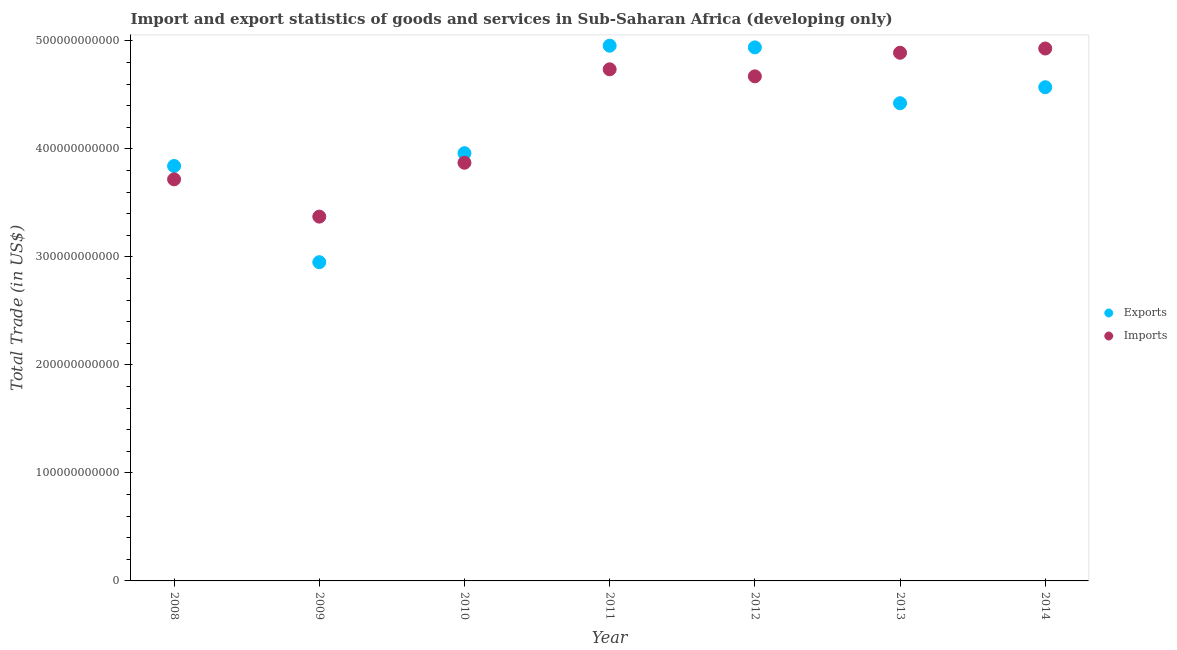What is the imports of goods and services in 2010?
Your answer should be compact. 3.87e+11. Across all years, what is the maximum imports of goods and services?
Offer a very short reply. 4.93e+11. Across all years, what is the minimum imports of goods and services?
Keep it short and to the point. 3.37e+11. What is the total export of goods and services in the graph?
Offer a very short reply. 2.96e+12. What is the difference between the imports of goods and services in 2010 and that in 2011?
Give a very brief answer. -8.65e+1. What is the difference between the export of goods and services in 2010 and the imports of goods and services in 2009?
Give a very brief answer. 5.87e+1. What is the average imports of goods and services per year?
Offer a terse response. 4.31e+11. In the year 2013, what is the difference between the imports of goods and services and export of goods and services?
Ensure brevity in your answer.  4.67e+1. In how many years, is the imports of goods and services greater than 160000000000 US$?
Your answer should be very brief. 7. What is the ratio of the export of goods and services in 2009 to that in 2014?
Provide a short and direct response. 0.65. Is the export of goods and services in 2011 less than that in 2012?
Make the answer very short. No. Is the difference between the imports of goods and services in 2012 and 2014 greater than the difference between the export of goods and services in 2012 and 2014?
Provide a succinct answer. No. What is the difference between the highest and the second highest export of goods and services?
Give a very brief answer. 1.56e+09. What is the difference between the highest and the lowest export of goods and services?
Your answer should be compact. 2.00e+11. Is the imports of goods and services strictly less than the export of goods and services over the years?
Give a very brief answer. No. What is the difference between two consecutive major ticks on the Y-axis?
Provide a succinct answer. 1.00e+11. Are the values on the major ticks of Y-axis written in scientific E-notation?
Offer a terse response. No. Does the graph contain any zero values?
Your answer should be very brief. No. Does the graph contain grids?
Ensure brevity in your answer.  No. How are the legend labels stacked?
Your answer should be very brief. Vertical. What is the title of the graph?
Offer a very short reply. Import and export statistics of goods and services in Sub-Saharan Africa (developing only). What is the label or title of the Y-axis?
Your answer should be very brief. Total Trade (in US$). What is the Total Trade (in US$) in Exports in 2008?
Ensure brevity in your answer.  3.84e+11. What is the Total Trade (in US$) in Imports in 2008?
Provide a succinct answer. 3.72e+11. What is the Total Trade (in US$) in Exports in 2009?
Keep it short and to the point. 2.95e+11. What is the Total Trade (in US$) of Imports in 2009?
Your response must be concise. 3.37e+11. What is the Total Trade (in US$) in Exports in 2010?
Offer a very short reply. 3.96e+11. What is the Total Trade (in US$) in Imports in 2010?
Provide a succinct answer. 3.87e+11. What is the Total Trade (in US$) in Exports in 2011?
Offer a terse response. 4.95e+11. What is the Total Trade (in US$) of Imports in 2011?
Your response must be concise. 4.74e+11. What is the Total Trade (in US$) in Exports in 2012?
Provide a short and direct response. 4.94e+11. What is the Total Trade (in US$) in Imports in 2012?
Provide a short and direct response. 4.67e+11. What is the Total Trade (in US$) in Exports in 2013?
Make the answer very short. 4.42e+11. What is the Total Trade (in US$) of Imports in 2013?
Make the answer very short. 4.89e+11. What is the Total Trade (in US$) of Exports in 2014?
Your response must be concise. 4.57e+11. What is the Total Trade (in US$) of Imports in 2014?
Your response must be concise. 4.93e+11. Across all years, what is the maximum Total Trade (in US$) in Exports?
Provide a succinct answer. 4.95e+11. Across all years, what is the maximum Total Trade (in US$) of Imports?
Your response must be concise. 4.93e+11. Across all years, what is the minimum Total Trade (in US$) in Exports?
Ensure brevity in your answer.  2.95e+11. Across all years, what is the minimum Total Trade (in US$) in Imports?
Offer a very short reply. 3.37e+11. What is the total Total Trade (in US$) in Exports in the graph?
Give a very brief answer. 2.96e+12. What is the total Total Trade (in US$) of Imports in the graph?
Make the answer very short. 3.02e+12. What is the difference between the Total Trade (in US$) in Exports in 2008 and that in 2009?
Make the answer very short. 8.91e+1. What is the difference between the Total Trade (in US$) of Imports in 2008 and that in 2009?
Ensure brevity in your answer.  3.45e+1. What is the difference between the Total Trade (in US$) of Exports in 2008 and that in 2010?
Ensure brevity in your answer.  -1.19e+1. What is the difference between the Total Trade (in US$) in Imports in 2008 and that in 2010?
Make the answer very short. -1.54e+1. What is the difference between the Total Trade (in US$) in Exports in 2008 and that in 2011?
Your answer should be very brief. -1.11e+11. What is the difference between the Total Trade (in US$) of Imports in 2008 and that in 2011?
Ensure brevity in your answer.  -1.02e+11. What is the difference between the Total Trade (in US$) in Exports in 2008 and that in 2012?
Keep it short and to the point. -1.10e+11. What is the difference between the Total Trade (in US$) in Imports in 2008 and that in 2012?
Keep it short and to the point. -9.54e+1. What is the difference between the Total Trade (in US$) of Exports in 2008 and that in 2013?
Offer a terse response. -5.81e+1. What is the difference between the Total Trade (in US$) in Imports in 2008 and that in 2013?
Provide a short and direct response. -1.17e+11. What is the difference between the Total Trade (in US$) in Exports in 2008 and that in 2014?
Ensure brevity in your answer.  -7.29e+1. What is the difference between the Total Trade (in US$) of Imports in 2008 and that in 2014?
Provide a short and direct response. -1.21e+11. What is the difference between the Total Trade (in US$) of Exports in 2009 and that in 2010?
Your answer should be compact. -1.01e+11. What is the difference between the Total Trade (in US$) in Imports in 2009 and that in 2010?
Your answer should be compact. -4.99e+1. What is the difference between the Total Trade (in US$) of Exports in 2009 and that in 2011?
Your answer should be very brief. -2.00e+11. What is the difference between the Total Trade (in US$) in Imports in 2009 and that in 2011?
Your response must be concise. -1.36e+11. What is the difference between the Total Trade (in US$) of Exports in 2009 and that in 2012?
Provide a short and direct response. -1.99e+11. What is the difference between the Total Trade (in US$) in Imports in 2009 and that in 2012?
Provide a short and direct response. -1.30e+11. What is the difference between the Total Trade (in US$) of Exports in 2009 and that in 2013?
Make the answer very short. -1.47e+11. What is the difference between the Total Trade (in US$) in Imports in 2009 and that in 2013?
Provide a short and direct response. -1.52e+11. What is the difference between the Total Trade (in US$) in Exports in 2009 and that in 2014?
Provide a short and direct response. -1.62e+11. What is the difference between the Total Trade (in US$) in Imports in 2009 and that in 2014?
Offer a terse response. -1.56e+11. What is the difference between the Total Trade (in US$) in Exports in 2010 and that in 2011?
Make the answer very short. -9.95e+1. What is the difference between the Total Trade (in US$) in Imports in 2010 and that in 2011?
Make the answer very short. -8.65e+1. What is the difference between the Total Trade (in US$) of Exports in 2010 and that in 2012?
Ensure brevity in your answer.  -9.79e+1. What is the difference between the Total Trade (in US$) in Imports in 2010 and that in 2012?
Provide a short and direct response. -8.00e+1. What is the difference between the Total Trade (in US$) in Exports in 2010 and that in 2013?
Offer a terse response. -4.62e+1. What is the difference between the Total Trade (in US$) of Imports in 2010 and that in 2013?
Your response must be concise. -1.02e+11. What is the difference between the Total Trade (in US$) of Exports in 2010 and that in 2014?
Provide a succinct answer. -6.11e+1. What is the difference between the Total Trade (in US$) in Imports in 2010 and that in 2014?
Keep it short and to the point. -1.06e+11. What is the difference between the Total Trade (in US$) of Exports in 2011 and that in 2012?
Ensure brevity in your answer.  1.56e+09. What is the difference between the Total Trade (in US$) in Imports in 2011 and that in 2012?
Keep it short and to the point. 6.51e+09. What is the difference between the Total Trade (in US$) of Exports in 2011 and that in 2013?
Your answer should be compact. 5.33e+1. What is the difference between the Total Trade (in US$) of Imports in 2011 and that in 2013?
Offer a very short reply. -1.53e+1. What is the difference between the Total Trade (in US$) of Exports in 2011 and that in 2014?
Your answer should be compact. 3.84e+1. What is the difference between the Total Trade (in US$) of Imports in 2011 and that in 2014?
Offer a very short reply. -1.93e+1. What is the difference between the Total Trade (in US$) of Exports in 2012 and that in 2013?
Provide a succinct answer. 5.17e+1. What is the difference between the Total Trade (in US$) of Imports in 2012 and that in 2013?
Your answer should be very brief. -2.18e+1. What is the difference between the Total Trade (in US$) in Exports in 2012 and that in 2014?
Offer a very short reply. 3.69e+1. What is the difference between the Total Trade (in US$) of Imports in 2012 and that in 2014?
Make the answer very short. -2.58e+1. What is the difference between the Total Trade (in US$) of Exports in 2013 and that in 2014?
Your response must be concise. -1.48e+1. What is the difference between the Total Trade (in US$) in Imports in 2013 and that in 2014?
Give a very brief answer. -3.94e+09. What is the difference between the Total Trade (in US$) of Exports in 2008 and the Total Trade (in US$) of Imports in 2009?
Your response must be concise. 4.69e+1. What is the difference between the Total Trade (in US$) of Exports in 2008 and the Total Trade (in US$) of Imports in 2010?
Provide a succinct answer. -3.01e+09. What is the difference between the Total Trade (in US$) in Exports in 2008 and the Total Trade (in US$) in Imports in 2011?
Provide a short and direct response. -8.95e+1. What is the difference between the Total Trade (in US$) of Exports in 2008 and the Total Trade (in US$) of Imports in 2012?
Offer a terse response. -8.30e+1. What is the difference between the Total Trade (in US$) of Exports in 2008 and the Total Trade (in US$) of Imports in 2013?
Your answer should be compact. -1.05e+11. What is the difference between the Total Trade (in US$) of Exports in 2008 and the Total Trade (in US$) of Imports in 2014?
Ensure brevity in your answer.  -1.09e+11. What is the difference between the Total Trade (in US$) in Exports in 2009 and the Total Trade (in US$) in Imports in 2010?
Your answer should be compact. -9.21e+1. What is the difference between the Total Trade (in US$) of Exports in 2009 and the Total Trade (in US$) of Imports in 2011?
Provide a succinct answer. -1.79e+11. What is the difference between the Total Trade (in US$) of Exports in 2009 and the Total Trade (in US$) of Imports in 2012?
Provide a short and direct response. -1.72e+11. What is the difference between the Total Trade (in US$) of Exports in 2009 and the Total Trade (in US$) of Imports in 2013?
Your answer should be compact. -1.94e+11. What is the difference between the Total Trade (in US$) of Exports in 2009 and the Total Trade (in US$) of Imports in 2014?
Keep it short and to the point. -1.98e+11. What is the difference between the Total Trade (in US$) of Exports in 2010 and the Total Trade (in US$) of Imports in 2011?
Your answer should be very brief. -7.76e+1. What is the difference between the Total Trade (in US$) in Exports in 2010 and the Total Trade (in US$) in Imports in 2012?
Your response must be concise. -7.11e+1. What is the difference between the Total Trade (in US$) in Exports in 2010 and the Total Trade (in US$) in Imports in 2013?
Offer a very short reply. -9.30e+1. What is the difference between the Total Trade (in US$) in Exports in 2010 and the Total Trade (in US$) in Imports in 2014?
Give a very brief answer. -9.69e+1. What is the difference between the Total Trade (in US$) in Exports in 2011 and the Total Trade (in US$) in Imports in 2012?
Keep it short and to the point. 2.84e+1. What is the difference between the Total Trade (in US$) of Exports in 2011 and the Total Trade (in US$) of Imports in 2013?
Make the answer very short. 6.54e+09. What is the difference between the Total Trade (in US$) in Exports in 2011 and the Total Trade (in US$) in Imports in 2014?
Make the answer very short. 2.59e+09. What is the difference between the Total Trade (in US$) of Exports in 2012 and the Total Trade (in US$) of Imports in 2013?
Your response must be concise. 4.97e+09. What is the difference between the Total Trade (in US$) in Exports in 2012 and the Total Trade (in US$) in Imports in 2014?
Ensure brevity in your answer.  1.03e+09. What is the difference between the Total Trade (in US$) in Exports in 2013 and the Total Trade (in US$) in Imports in 2014?
Provide a short and direct response. -5.07e+1. What is the average Total Trade (in US$) of Exports per year?
Provide a short and direct response. 4.23e+11. What is the average Total Trade (in US$) of Imports per year?
Your answer should be very brief. 4.31e+11. In the year 2008, what is the difference between the Total Trade (in US$) in Exports and Total Trade (in US$) in Imports?
Keep it short and to the point. 1.24e+1. In the year 2009, what is the difference between the Total Trade (in US$) in Exports and Total Trade (in US$) in Imports?
Offer a terse response. -4.22e+1. In the year 2010, what is the difference between the Total Trade (in US$) of Exports and Total Trade (in US$) of Imports?
Provide a short and direct response. 8.85e+09. In the year 2011, what is the difference between the Total Trade (in US$) in Exports and Total Trade (in US$) in Imports?
Provide a succinct answer. 2.19e+1. In the year 2012, what is the difference between the Total Trade (in US$) in Exports and Total Trade (in US$) in Imports?
Your answer should be very brief. 2.68e+1. In the year 2013, what is the difference between the Total Trade (in US$) of Exports and Total Trade (in US$) of Imports?
Provide a succinct answer. -4.67e+1. In the year 2014, what is the difference between the Total Trade (in US$) in Exports and Total Trade (in US$) in Imports?
Offer a very short reply. -3.59e+1. What is the ratio of the Total Trade (in US$) of Exports in 2008 to that in 2009?
Your answer should be compact. 1.3. What is the ratio of the Total Trade (in US$) of Imports in 2008 to that in 2009?
Provide a succinct answer. 1.1. What is the ratio of the Total Trade (in US$) in Exports in 2008 to that in 2010?
Make the answer very short. 0.97. What is the ratio of the Total Trade (in US$) of Imports in 2008 to that in 2010?
Keep it short and to the point. 0.96. What is the ratio of the Total Trade (in US$) in Exports in 2008 to that in 2011?
Your response must be concise. 0.78. What is the ratio of the Total Trade (in US$) in Imports in 2008 to that in 2011?
Keep it short and to the point. 0.78. What is the ratio of the Total Trade (in US$) of Exports in 2008 to that in 2012?
Provide a succinct answer. 0.78. What is the ratio of the Total Trade (in US$) in Imports in 2008 to that in 2012?
Offer a terse response. 0.8. What is the ratio of the Total Trade (in US$) of Exports in 2008 to that in 2013?
Make the answer very short. 0.87. What is the ratio of the Total Trade (in US$) of Imports in 2008 to that in 2013?
Provide a short and direct response. 0.76. What is the ratio of the Total Trade (in US$) of Exports in 2008 to that in 2014?
Ensure brevity in your answer.  0.84. What is the ratio of the Total Trade (in US$) of Imports in 2008 to that in 2014?
Your answer should be compact. 0.75. What is the ratio of the Total Trade (in US$) of Exports in 2009 to that in 2010?
Keep it short and to the point. 0.75. What is the ratio of the Total Trade (in US$) of Imports in 2009 to that in 2010?
Offer a terse response. 0.87. What is the ratio of the Total Trade (in US$) of Exports in 2009 to that in 2011?
Your answer should be compact. 0.6. What is the ratio of the Total Trade (in US$) of Imports in 2009 to that in 2011?
Provide a succinct answer. 0.71. What is the ratio of the Total Trade (in US$) in Exports in 2009 to that in 2012?
Offer a very short reply. 0.6. What is the ratio of the Total Trade (in US$) in Imports in 2009 to that in 2012?
Ensure brevity in your answer.  0.72. What is the ratio of the Total Trade (in US$) of Exports in 2009 to that in 2013?
Make the answer very short. 0.67. What is the ratio of the Total Trade (in US$) in Imports in 2009 to that in 2013?
Provide a short and direct response. 0.69. What is the ratio of the Total Trade (in US$) of Exports in 2009 to that in 2014?
Your answer should be very brief. 0.65. What is the ratio of the Total Trade (in US$) of Imports in 2009 to that in 2014?
Give a very brief answer. 0.68. What is the ratio of the Total Trade (in US$) of Exports in 2010 to that in 2011?
Make the answer very short. 0.8. What is the ratio of the Total Trade (in US$) in Imports in 2010 to that in 2011?
Make the answer very short. 0.82. What is the ratio of the Total Trade (in US$) of Exports in 2010 to that in 2012?
Your answer should be compact. 0.8. What is the ratio of the Total Trade (in US$) in Imports in 2010 to that in 2012?
Offer a terse response. 0.83. What is the ratio of the Total Trade (in US$) of Exports in 2010 to that in 2013?
Give a very brief answer. 0.9. What is the ratio of the Total Trade (in US$) of Imports in 2010 to that in 2013?
Keep it short and to the point. 0.79. What is the ratio of the Total Trade (in US$) in Exports in 2010 to that in 2014?
Offer a terse response. 0.87. What is the ratio of the Total Trade (in US$) of Imports in 2010 to that in 2014?
Your answer should be compact. 0.79. What is the ratio of the Total Trade (in US$) of Imports in 2011 to that in 2012?
Ensure brevity in your answer.  1.01. What is the ratio of the Total Trade (in US$) of Exports in 2011 to that in 2013?
Your answer should be compact. 1.12. What is the ratio of the Total Trade (in US$) of Imports in 2011 to that in 2013?
Your answer should be very brief. 0.97. What is the ratio of the Total Trade (in US$) of Exports in 2011 to that in 2014?
Your response must be concise. 1.08. What is the ratio of the Total Trade (in US$) of Imports in 2011 to that in 2014?
Give a very brief answer. 0.96. What is the ratio of the Total Trade (in US$) in Exports in 2012 to that in 2013?
Provide a succinct answer. 1.12. What is the ratio of the Total Trade (in US$) of Imports in 2012 to that in 2013?
Ensure brevity in your answer.  0.96. What is the ratio of the Total Trade (in US$) of Exports in 2012 to that in 2014?
Your response must be concise. 1.08. What is the ratio of the Total Trade (in US$) of Imports in 2012 to that in 2014?
Make the answer very short. 0.95. What is the ratio of the Total Trade (in US$) in Exports in 2013 to that in 2014?
Your answer should be compact. 0.97. What is the difference between the highest and the second highest Total Trade (in US$) of Exports?
Provide a short and direct response. 1.56e+09. What is the difference between the highest and the second highest Total Trade (in US$) in Imports?
Your answer should be very brief. 3.94e+09. What is the difference between the highest and the lowest Total Trade (in US$) of Exports?
Offer a very short reply. 2.00e+11. What is the difference between the highest and the lowest Total Trade (in US$) in Imports?
Keep it short and to the point. 1.56e+11. 